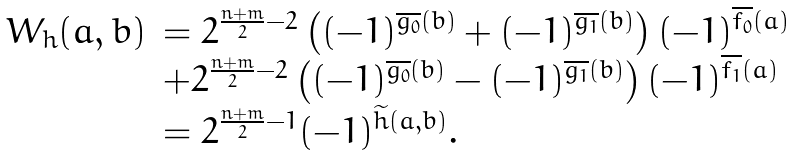<formula> <loc_0><loc_0><loc_500><loc_500>\begin{array} { r l } W _ { h } ( a , b ) & = 2 ^ { \frac { n + m } { 2 } - 2 } \left ( ( - 1 ) ^ { \overline { g _ { 0 } } ( b ) } + ( - 1 ) ^ { \overline { g _ { 1 } } ( b ) } \right ) ( - 1 ) ^ { \overline { f _ { 0 } } ( a ) } \\ & + 2 ^ { \frac { n + m } { 2 } - 2 } \left ( ( - 1 ) ^ { \overline { g _ { 0 } } ( b ) } - ( - 1 ) ^ { \overline { g _ { 1 } } ( b ) } \right ) ( - 1 ) ^ { \overline { f _ { 1 } } ( a ) } \\ & = 2 ^ { \frac { n + m } { 2 } - 1 } ( - 1 ) ^ { \widetilde { h } ( a , b ) } . \end{array}</formula> 